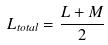<formula> <loc_0><loc_0><loc_500><loc_500>L _ { t o t a l } = \frac { L + M } { 2 }</formula> 